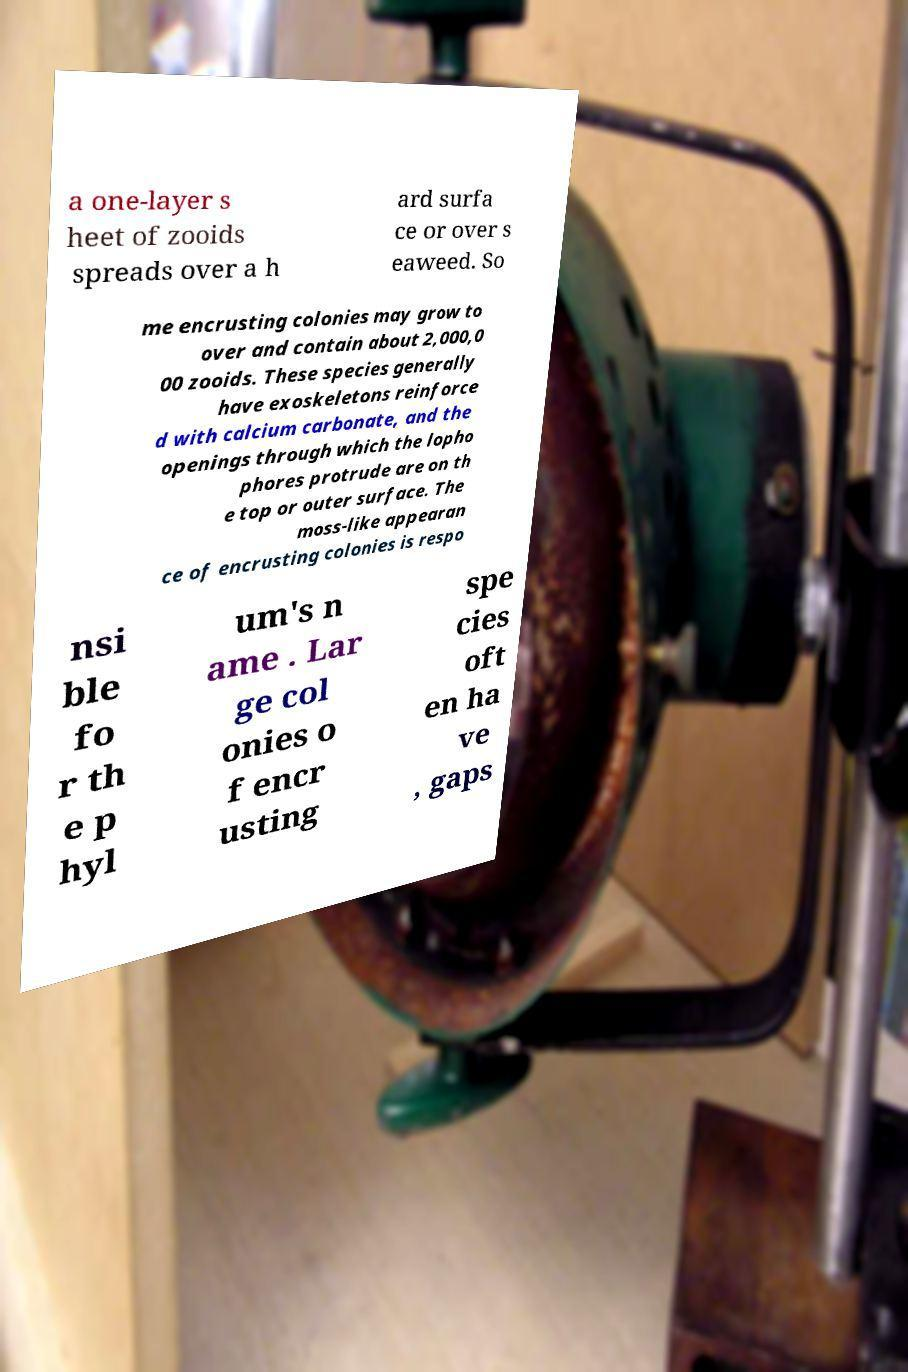I need the written content from this picture converted into text. Can you do that? a one-layer s heet of zooids spreads over a h ard surfa ce or over s eaweed. So me encrusting colonies may grow to over and contain about 2,000,0 00 zooids. These species generally have exoskeletons reinforce d with calcium carbonate, and the openings through which the lopho phores protrude are on th e top or outer surface. The moss-like appearan ce of encrusting colonies is respo nsi ble fo r th e p hyl um's n ame . Lar ge col onies o f encr usting spe cies oft en ha ve , gaps 